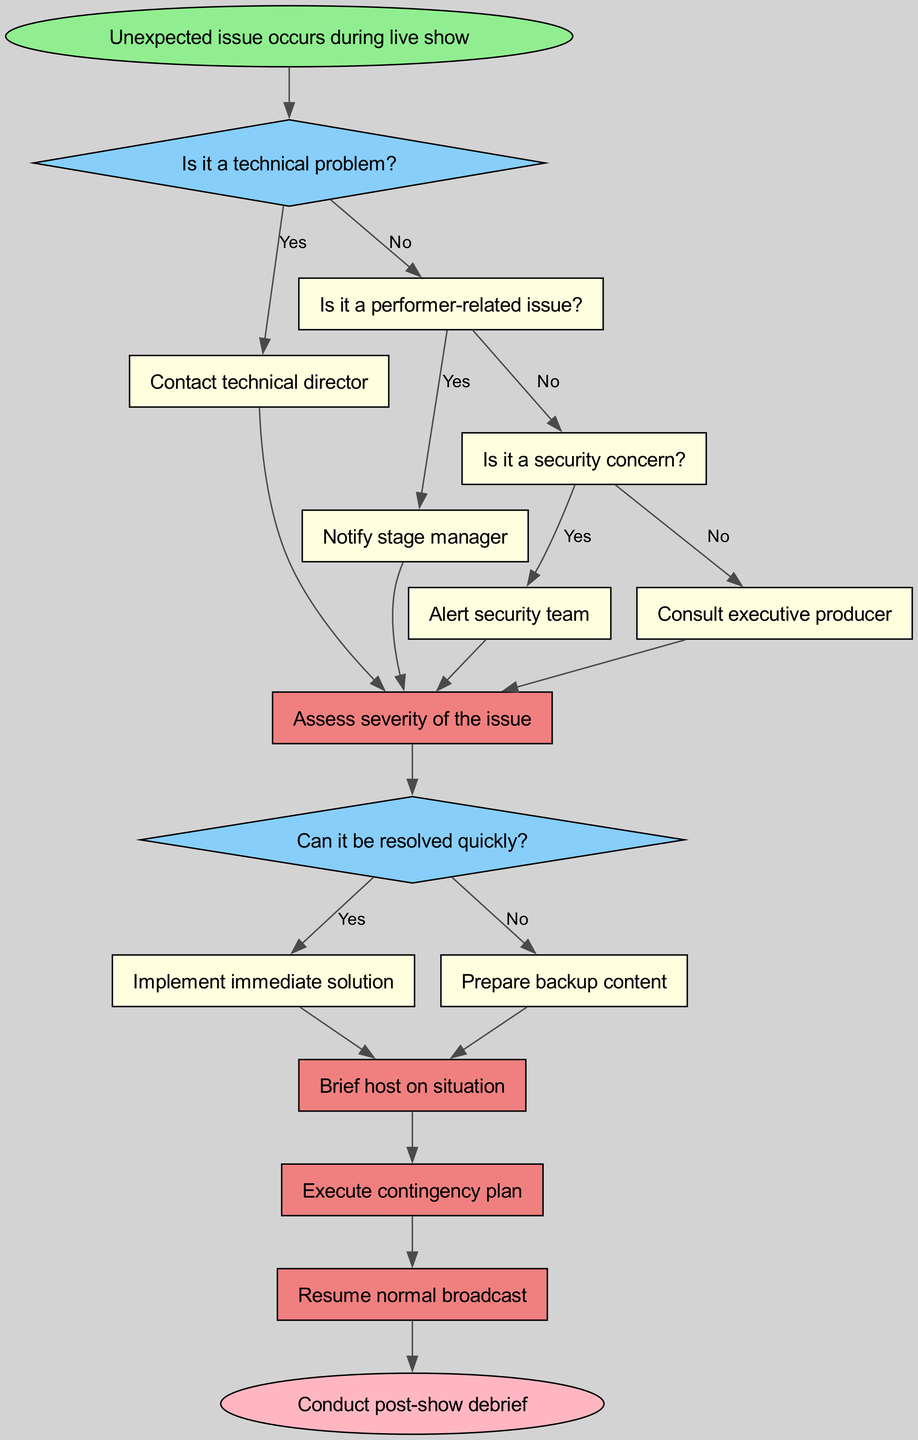What is the first action taken after an unexpected issue occurs during a live show? The diagram indicates that the flow begins with an "Unexpected issue occurs during live show" followed by a decision node. The first action is not outlined until one of the decision routes is taken, leading to "Assess severity of the issue."
Answer: Assess severity of the issue How many decision nodes are present in the diagram? The diagram has two decision nodes labeled "decision1" and "decision2." By counting them, we can confirm that the total number of decision nodes is two.
Answer: 2 What happens if it's determined that the issue can be resolved quickly? If the issue can be resolved quickly (indicated by the "Yes" branch of "decision2"), the next action in the flow is to "Implement immediate solution." This shows that the flowchart follows a linear process that directly leads to the next step based on the decision outcome.
Answer: Implement immediate solution What should be done if the issue is not a technical problem and not performer-related? If the issue is neither a technical problem nor a performer-related issue, the flow chart suggests asking if it's a security concern. If the answer is "No," you then proceed to "Consult executive producer," indicating a clear alternative route in the flow for issues falling outside of those two categories.
Answer: Consult executive producer What is the final action to be taken in the protocol? The last step in the diagram, following all actions involved in crisis management, is "Conduct post-show debrief." This indicates closure of the process, allowing for reflection and analysis after the live show concludes.
Answer: Conduct post-show debrief 